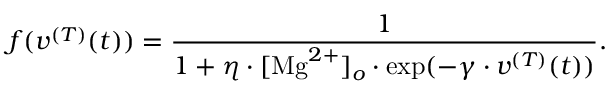<formula> <loc_0><loc_0><loc_500><loc_500>f ( v ^ { ( T ) } ( t ) ) = \frac { 1 } { 1 + \eta \cdot [ M g ^ { 2 + } ] _ { o } \cdot \exp ( - \gamma \cdot v ^ { ( T ) } ( t ) ) } .</formula> 